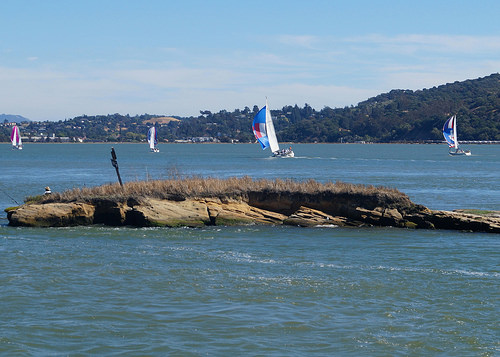<image>
Can you confirm if the sailboat is on the water? Yes. Looking at the image, I can see the sailboat is positioned on top of the water, with the water providing support. 